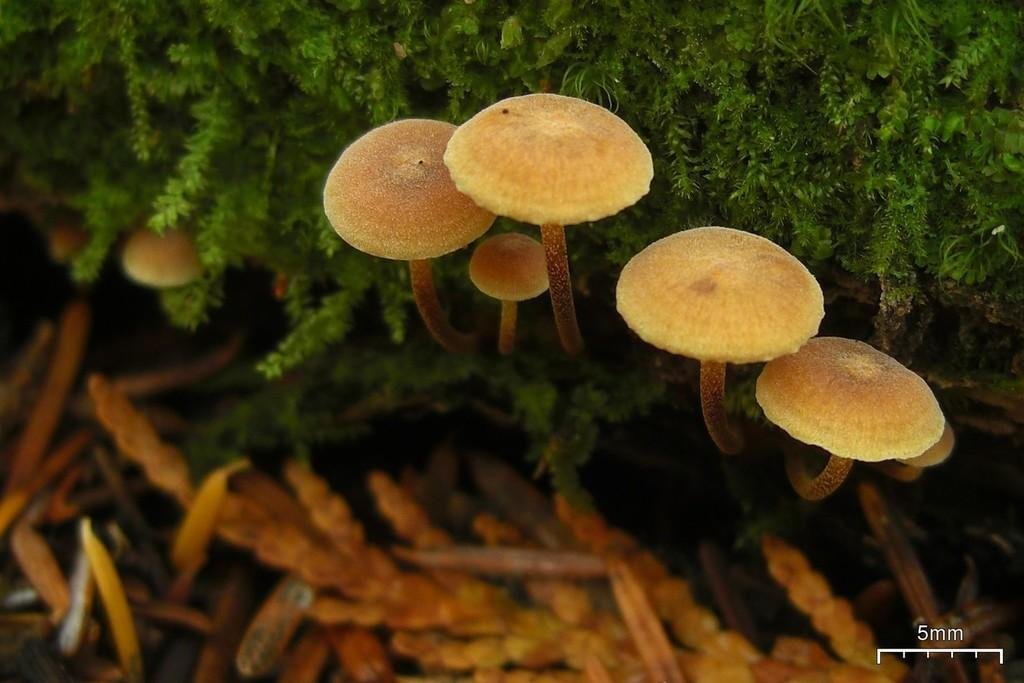What type of fungi can be seen in the image? There are mushrooms in the image. What other type of plant is present in the image? There are green plants in the image. How would you describe the clarity of the image? The image is slightly blurred. What tool is visible in the image? There is a scale visible in the image. Can you tell me how many flowers are present in the image? There are no flowers mentioned or visible in the image; it features mushrooms and green plants. What type of stretch is being performed by the mushrooms in the image? There is no stretch being performed by the mushrooms in the image; they are stationary fungi. 